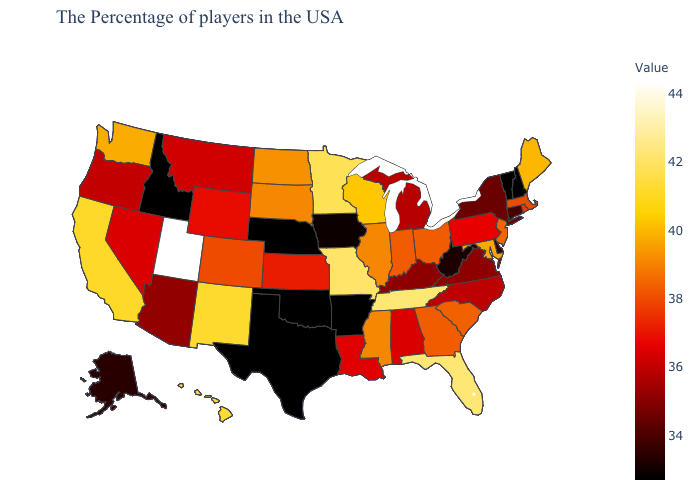Does Texas have the lowest value in the USA?
Concise answer only. Yes. Is the legend a continuous bar?
Quick response, please. Yes. Which states have the lowest value in the Northeast?
Write a very short answer. New Hampshire, Vermont. Does Idaho have a lower value than Georgia?
Write a very short answer. Yes. 